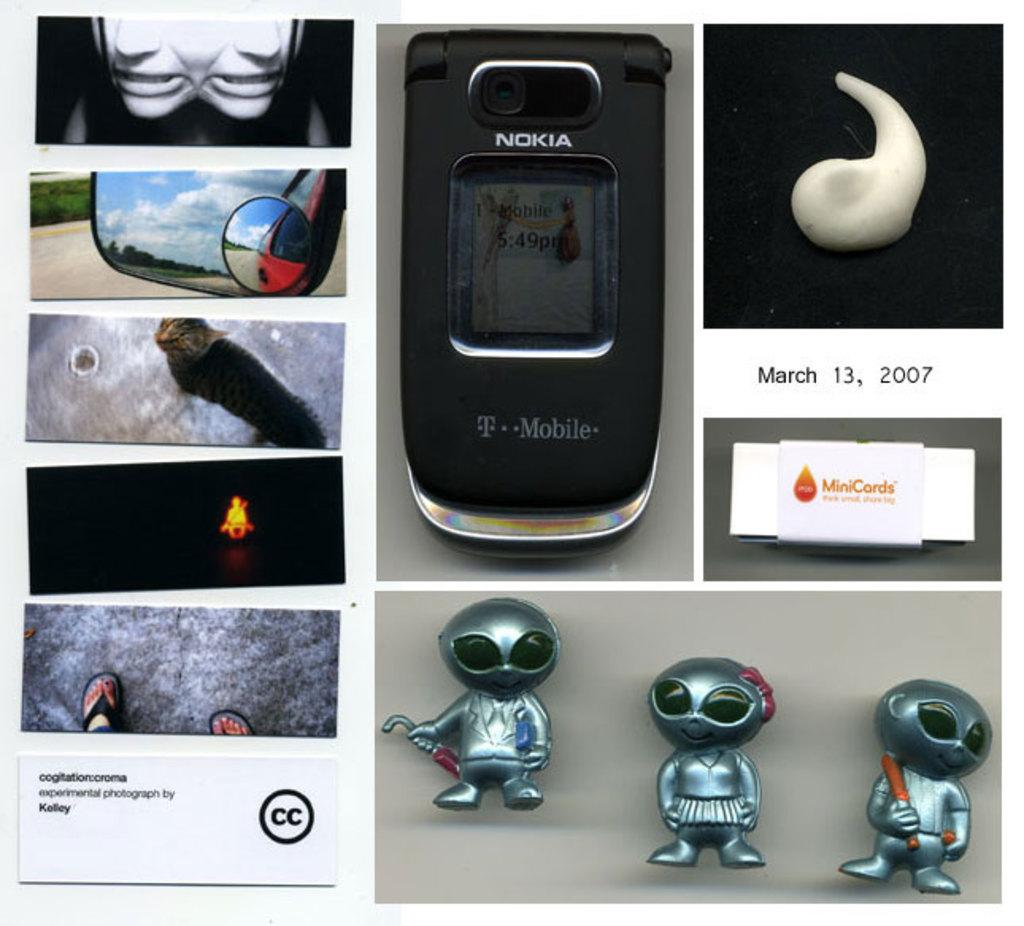<image>
Describe the image concisely. A collage of photos with a black Nokia phone in the center. 